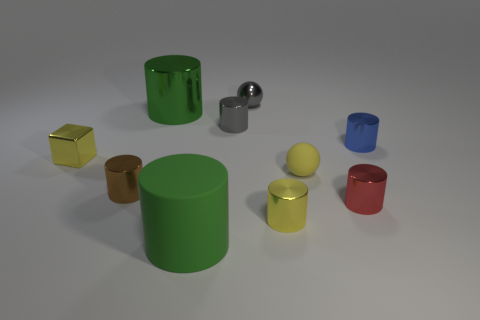What number of large green things have the same shape as the blue object?
Provide a succinct answer. 2. There is a yellow object that is in front of the tiny brown shiny object; is its shape the same as the small gray thing in front of the tiny shiny ball?
Offer a terse response. Yes. What number of objects are either red things or metallic cylinders left of the big green matte cylinder?
Your answer should be very brief. 3. What is the shape of the small matte object that is the same color as the tiny metallic block?
Your answer should be very brief. Sphere. How many gray cylinders have the same size as the yellow rubber object?
Make the answer very short. 1. What number of gray things are either small spheres or cubes?
Offer a very short reply. 1. There is a small shiny object behind the gray thing that is in front of the tiny gray metal ball; what is its shape?
Keep it short and to the point. Sphere. What shape is the blue object that is the same size as the yellow matte object?
Give a very brief answer. Cylinder. Are there any objects that have the same color as the metallic cube?
Provide a succinct answer. Yes. Is the number of red shiny things that are on the left side of the red object the same as the number of green cylinders that are on the right side of the green matte cylinder?
Your answer should be very brief. Yes. 